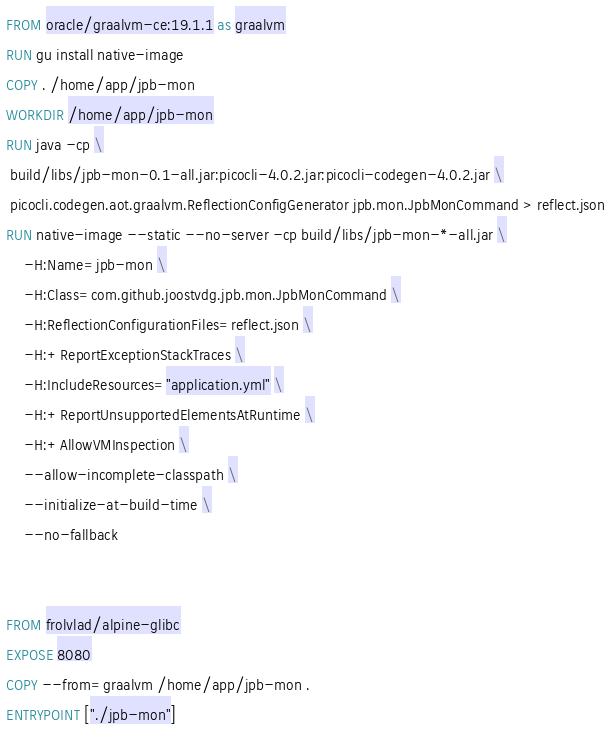<code> <loc_0><loc_0><loc_500><loc_500><_Dockerfile_>FROM oracle/graalvm-ce:19.1.1 as graalvm
RUN gu install native-image
COPY . /home/app/jpb-mon
WORKDIR /home/app/jpb-mon
RUN java -cp \
 build/libs/jpb-mon-0.1-all.jar:picocli-4.0.2.jar:picocli-codegen-4.0.2.jar \
 picocli.codegen.aot.graalvm.ReflectionConfigGenerator jpb.mon.JpbMonCommand > reflect.json
RUN native-image --static --no-server -cp build/libs/jpb-mon-*-all.jar \
    -H:Name=jpb-mon \
    -H:Class=com.github.joostvdg.jpb.mon.JpbMonCommand \
    -H:ReflectionConfigurationFiles=reflect.json \
    -H:+ReportExceptionStackTraces \
    -H:IncludeResources="application.yml" \
    -H:+ReportUnsupportedElementsAtRuntime \
    -H:+AllowVMInspection \
    --allow-incomplete-classpath \
    --initialize-at-build-time \
    --no-fallback


FROM frolvlad/alpine-glibc
EXPOSE 8080
COPY --from=graalvm /home/app/jpb-mon .
ENTRYPOINT ["./jpb-mon"]
</code> 